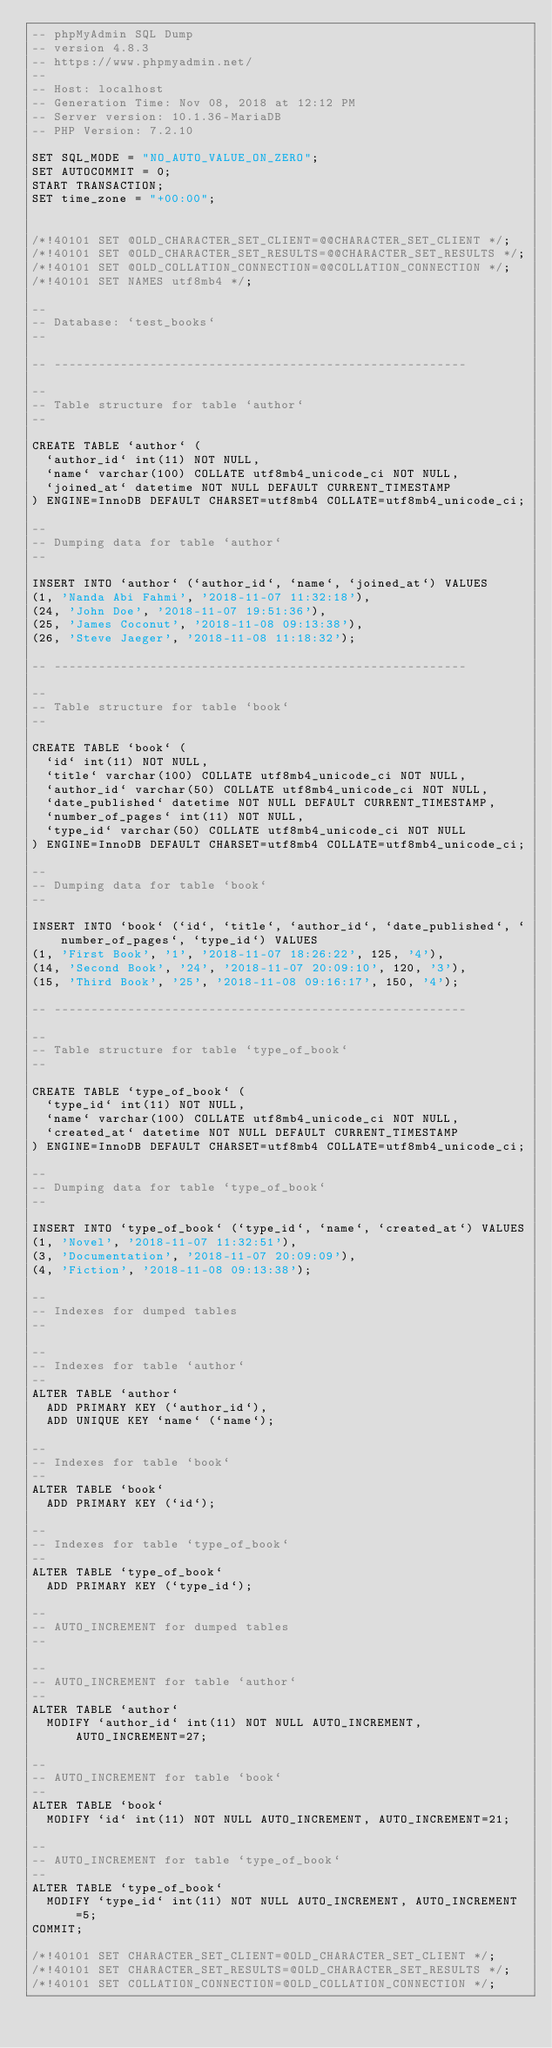<code> <loc_0><loc_0><loc_500><loc_500><_SQL_>-- phpMyAdmin SQL Dump
-- version 4.8.3
-- https://www.phpmyadmin.net/
--
-- Host: localhost
-- Generation Time: Nov 08, 2018 at 12:12 PM
-- Server version: 10.1.36-MariaDB
-- PHP Version: 7.2.10

SET SQL_MODE = "NO_AUTO_VALUE_ON_ZERO";
SET AUTOCOMMIT = 0;
START TRANSACTION;
SET time_zone = "+00:00";


/*!40101 SET @OLD_CHARACTER_SET_CLIENT=@@CHARACTER_SET_CLIENT */;
/*!40101 SET @OLD_CHARACTER_SET_RESULTS=@@CHARACTER_SET_RESULTS */;
/*!40101 SET @OLD_COLLATION_CONNECTION=@@COLLATION_CONNECTION */;
/*!40101 SET NAMES utf8mb4 */;

--
-- Database: `test_books`
--

-- --------------------------------------------------------

--
-- Table structure for table `author`
--

CREATE TABLE `author` (
  `author_id` int(11) NOT NULL,
  `name` varchar(100) COLLATE utf8mb4_unicode_ci NOT NULL,
  `joined_at` datetime NOT NULL DEFAULT CURRENT_TIMESTAMP
) ENGINE=InnoDB DEFAULT CHARSET=utf8mb4 COLLATE=utf8mb4_unicode_ci;

--
-- Dumping data for table `author`
--

INSERT INTO `author` (`author_id`, `name`, `joined_at`) VALUES
(1, 'Nanda Abi Fahmi', '2018-11-07 11:32:18'),
(24, 'John Doe', '2018-11-07 19:51:36'),
(25, 'James Coconut', '2018-11-08 09:13:38'),
(26, 'Steve Jaeger', '2018-11-08 11:18:32');

-- --------------------------------------------------------

--
-- Table structure for table `book`
--

CREATE TABLE `book` (
  `id` int(11) NOT NULL,
  `title` varchar(100) COLLATE utf8mb4_unicode_ci NOT NULL,
  `author_id` varchar(50) COLLATE utf8mb4_unicode_ci NOT NULL,
  `date_published` datetime NOT NULL DEFAULT CURRENT_TIMESTAMP,
  `number_of_pages` int(11) NOT NULL,
  `type_id` varchar(50) COLLATE utf8mb4_unicode_ci NOT NULL
) ENGINE=InnoDB DEFAULT CHARSET=utf8mb4 COLLATE=utf8mb4_unicode_ci;

--
-- Dumping data for table `book`
--

INSERT INTO `book` (`id`, `title`, `author_id`, `date_published`, `number_of_pages`, `type_id`) VALUES
(1, 'First Book', '1', '2018-11-07 18:26:22', 125, '4'),
(14, 'Second Book', '24', '2018-11-07 20:09:10', 120, '3'),
(15, 'Third Book', '25', '2018-11-08 09:16:17', 150, '4');

-- --------------------------------------------------------

--
-- Table structure for table `type_of_book`
--

CREATE TABLE `type_of_book` (
  `type_id` int(11) NOT NULL,
  `name` varchar(100) COLLATE utf8mb4_unicode_ci NOT NULL,
  `created_at` datetime NOT NULL DEFAULT CURRENT_TIMESTAMP
) ENGINE=InnoDB DEFAULT CHARSET=utf8mb4 COLLATE=utf8mb4_unicode_ci;

--
-- Dumping data for table `type_of_book`
--

INSERT INTO `type_of_book` (`type_id`, `name`, `created_at`) VALUES
(1, 'Novel', '2018-11-07 11:32:51'),
(3, 'Documentation', '2018-11-07 20:09:09'),
(4, 'Fiction', '2018-11-08 09:13:38');

--
-- Indexes for dumped tables
--

--
-- Indexes for table `author`
--
ALTER TABLE `author`
  ADD PRIMARY KEY (`author_id`),
  ADD UNIQUE KEY `name` (`name`);

--
-- Indexes for table `book`
--
ALTER TABLE `book`
  ADD PRIMARY KEY (`id`);

--
-- Indexes for table `type_of_book`
--
ALTER TABLE `type_of_book`
  ADD PRIMARY KEY (`type_id`);

--
-- AUTO_INCREMENT for dumped tables
--

--
-- AUTO_INCREMENT for table `author`
--
ALTER TABLE `author`
  MODIFY `author_id` int(11) NOT NULL AUTO_INCREMENT, AUTO_INCREMENT=27;

--
-- AUTO_INCREMENT for table `book`
--
ALTER TABLE `book`
  MODIFY `id` int(11) NOT NULL AUTO_INCREMENT, AUTO_INCREMENT=21;

--
-- AUTO_INCREMENT for table `type_of_book`
--
ALTER TABLE `type_of_book`
  MODIFY `type_id` int(11) NOT NULL AUTO_INCREMENT, AUTO_INCREMENT=5;
COMMIT;

/*!40101 SET CHARACTER_SET_CLIENT=@OLD_CHARACTER_SET_CLIENT */;
/*!40101 SET CHARACTER_SET_RESULTS=@OLD_CHARACTER_SET_RESULTS */;
/*!40101 SET COLLATION_CONNECTION=@OLD_COLLATION_CONNECTION */;
</code> 